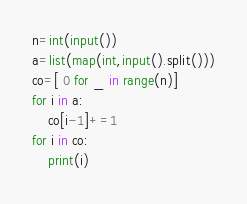Convert code to text. <code><loc_0><loc_0><loc_500><loc_500><_Python_>n=int(input())
a=list(map(int,input().split()))
co=[ 0 for _ in range(n)]
for i in a:
    co[i-1]+=1
for i in co:
    print(i)

</code> 